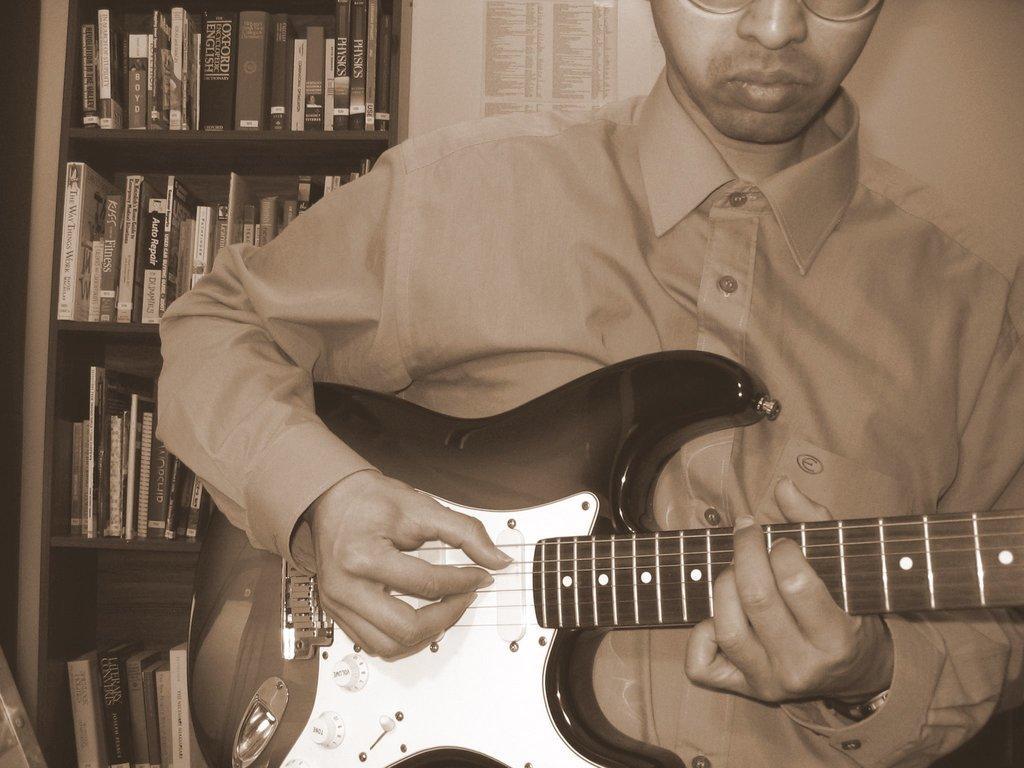Please provide a concise description of this image. In this image, we can see a person holding a guitar and in the background, there are books in the rack and we can see a paper on the wall. 